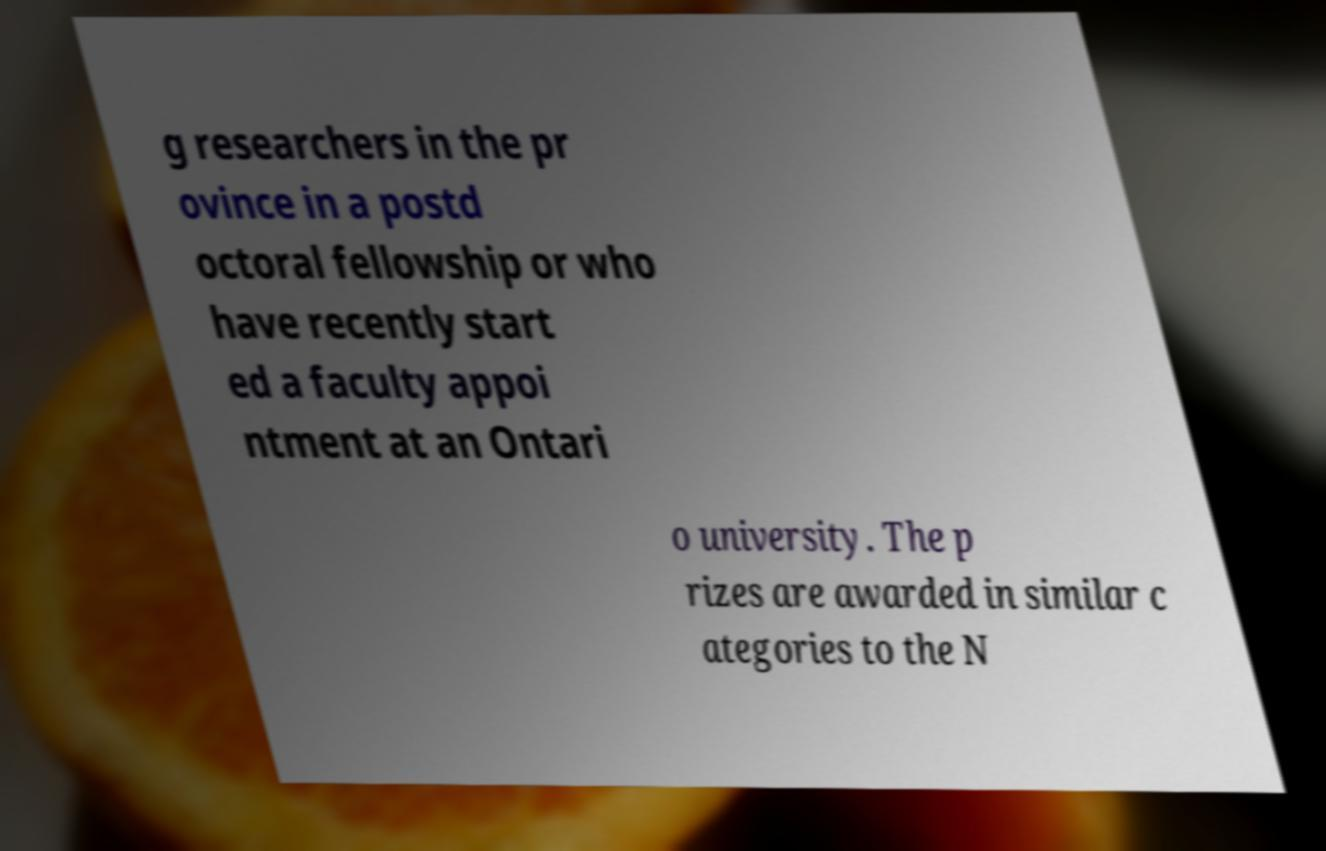For documentation purposes, I need the text within this image transcribed. Could you provide that? g researchers in the pr ovince in a postd octoral fellowship or who have recently start ed a faculty appoi ntment at an Ontari o university. The p rizes are awarded in similar c ategories to the N 